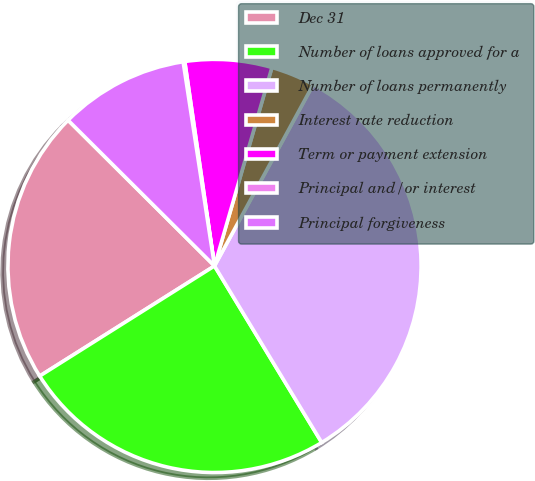Convert chart. <chart><loc_0><loc_0><loc_500><loc_500><pie_chart><fcel>Dec 31<fcel>Number of loans approved for a<fcel>Number of loans permanently<fcel>Interest rate reduction<fcel>Term or payment extension<fcel>Principal and/or interest<fcel>Principal forgiveness<nl><fcel>21.41%<fcel>24.74%<fcel>33.39%<fcel>3.45%<fcel>6.78%<fcel>0.13%<fcel>10.11%<nl></chart> 